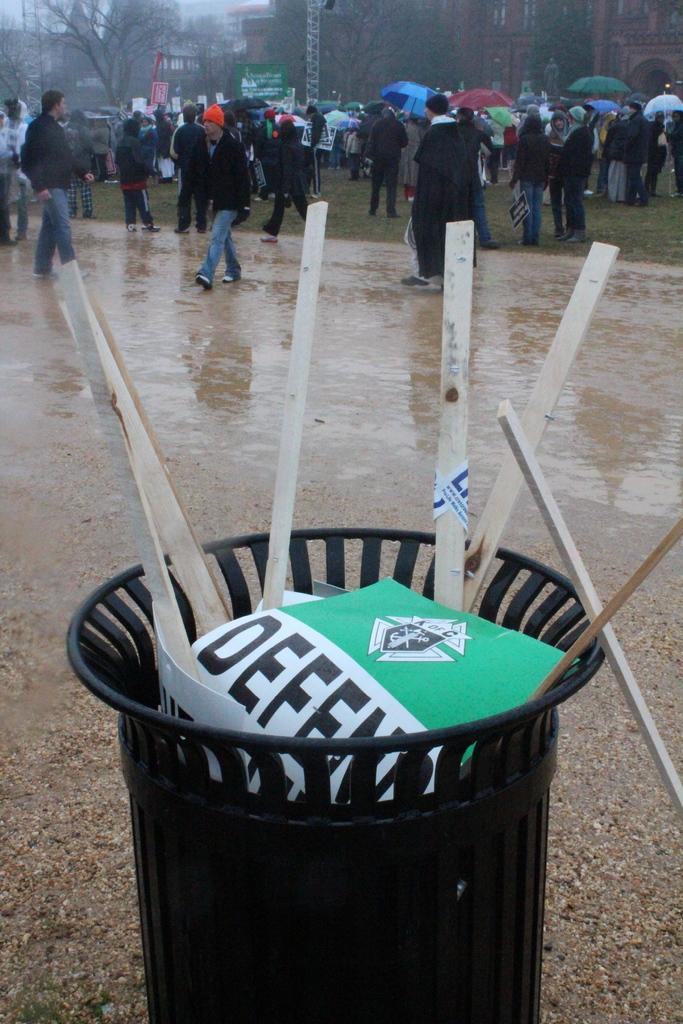<image>
Present a compact description of the photo's key features. A group of protesters and a bin with thrown out sings with "defe" visible. 